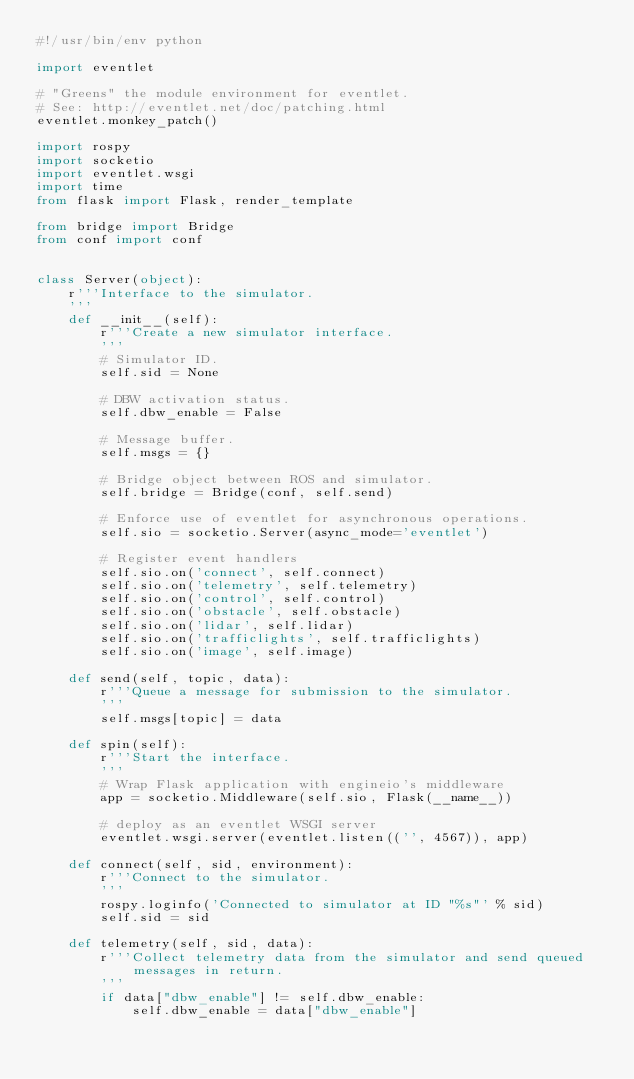Convert code to text. <code><loc_0><loc_0><loc_500><loc_500><_Python_>#!/usr/bin/env python

import eventlet

# "Greens" the module environment for eventlet.
# See: http://eventlet.net/doc/patching.html
eventlet.monkey_patch()

import rospy
import socketio
import eventlet.wsgi
import time
from flask import Flask, render_template

from bridge import Bridge
from conf import conf


class Server(object):
    r'''Interface to the simulator.
    '''
    def __init__(self):
        r'''Create a new simulator interface.
        '''
        # Simulator ID.
        self.sid = None

        # DBW activation status.
        self.dbw_enable = False

        # Message buffer.
        self.msgs = {}

        # Bridge object between ROS and simulator.
        self.bridge = Bridge(conf, self.send)

        # Enforce use of eventlet for asynchronous operations.
        self.sio = socketio.Server(async_mode='eventlet')

        # Register event handlers
        self.sio.on('connect', self.connect)
        self.sio.on('telemetry', self.telemetry)
        self.sio.on('control', self.control)
        self.sio.on('obstacle', self.obstacle)
        self.sio.on('lidar', self.lidar)
        self.sio.on('trafficlights', self.trafficlights)
        self.sio.on('image', self.image)

    def send(self, topic, data):
        r'''Queue a message for submission to the simulator.
        '''
        self.msgs[topic] = data

    def spin(self):
        r'''Start the interface.
        '''
        # Wrap Flask application with engineio's middleware
        app = socketio.Middleware(self.sio, Flask(__name__))

        # deploy as an eventlet WSGI server
        eventlet.wsgi.server(eventlet.listen(('', 4567)), app)

    def connect(self, sid, environment):
        r'''Connect to the simulator.
        '''
        rospy.loginfo('Connected to simulator at ID "%s"' % sid)
        self.sid = sid

    def telemetry(self, sid, data):
        r'''Collect telemetry data from the simulator and send queued messages in return.
        '''
        if data["dbw_enable"] != self.dbw_enable:
            self.dbw_enable = data["dbw_enable"]</code> 